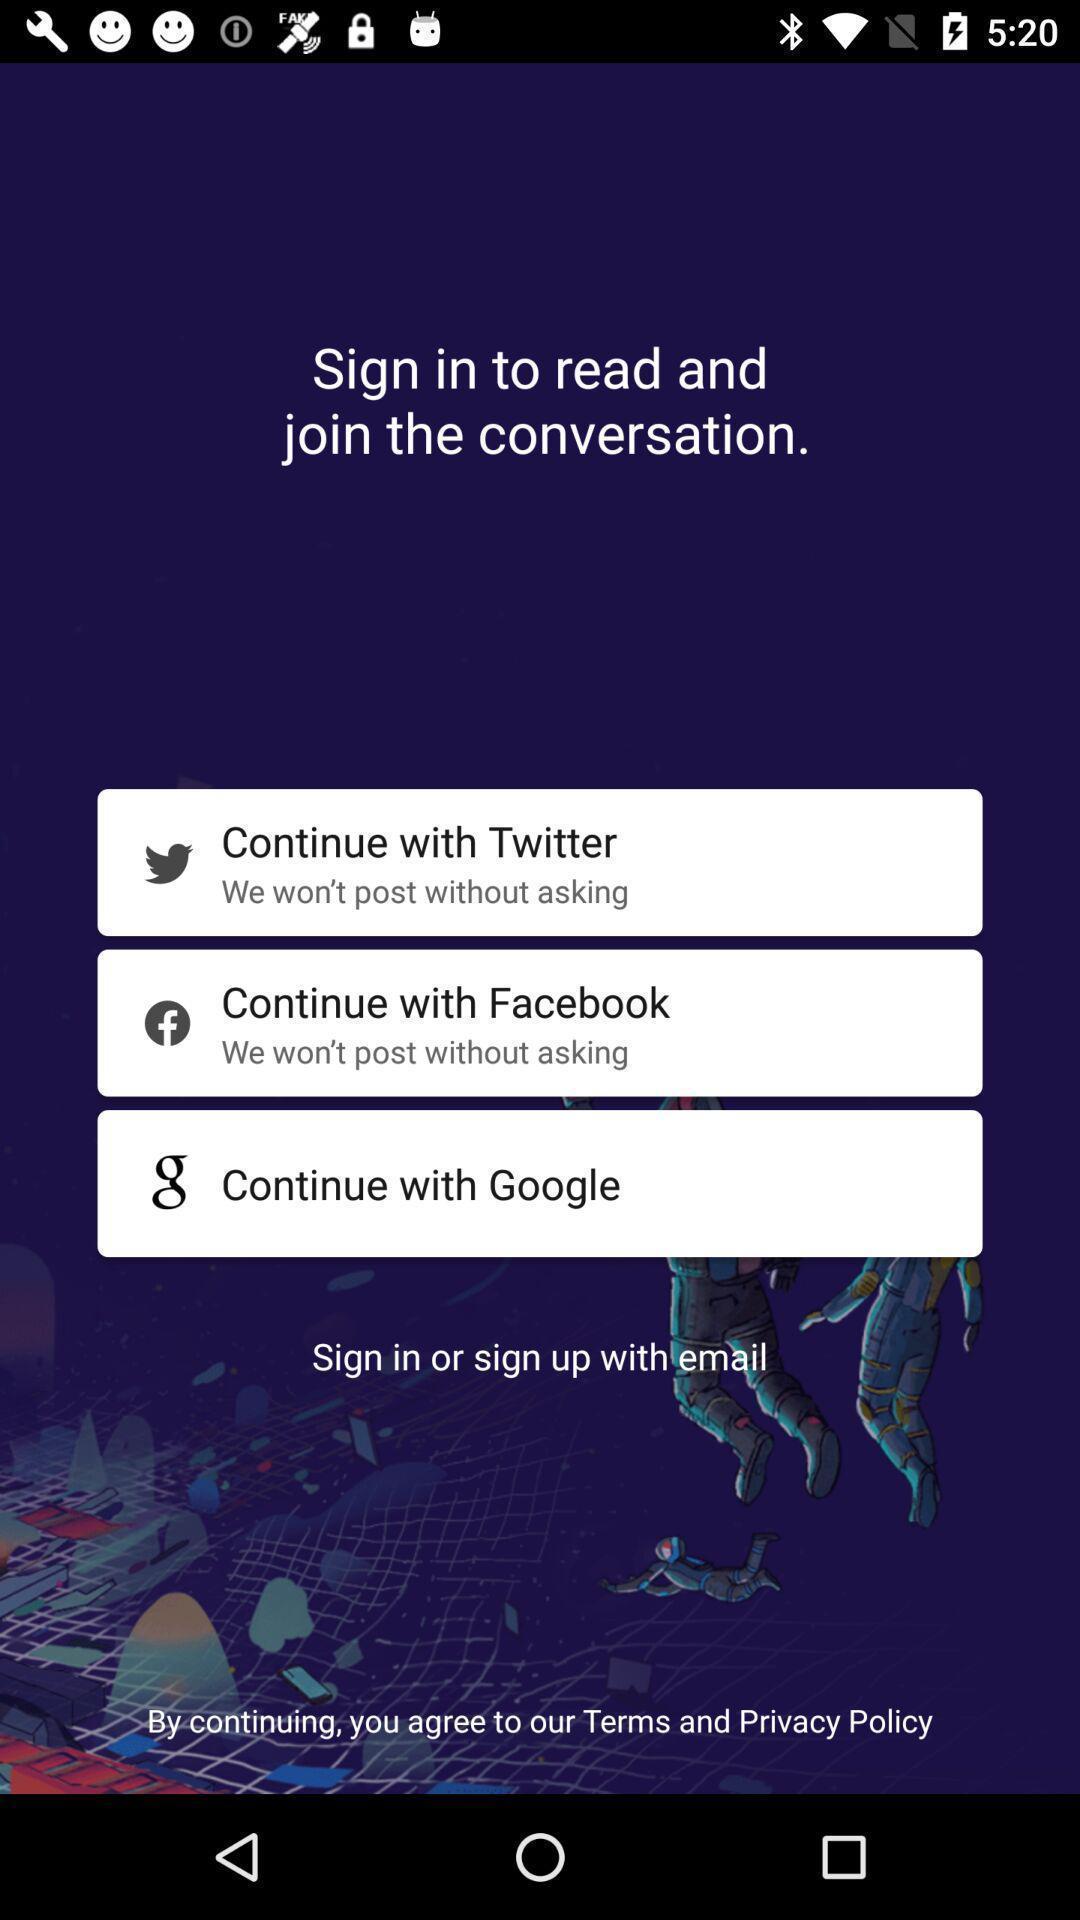Provide a detailed account of this screenshot. Welcome page of a digital publisher website. 